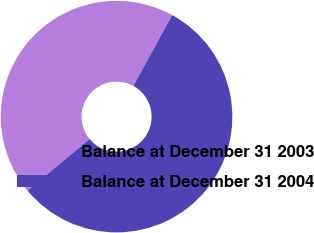<chart> <loc_0><loc_0><loc_500><loc_500><pie_chart><fcel>Balance at December 31 2003<fcel>Balance at December 31 2004<nl><fcel>44.01%<fcel>55.99%<nl></chart> 